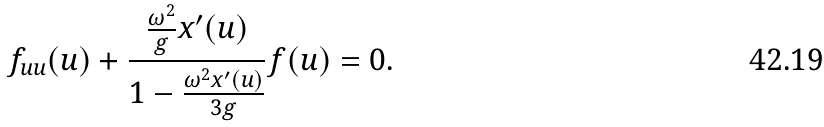Convert formula to latex. <formula><loc_0><loc_0><loc_500><loc_500>f _ { u u } ( u ) + \frac { \frac { \omega ^ { 2 } } { g } x ^ { \prime } ( u ) } { 1 - \frac { \omega ^ { 2 } x ^ { \prime } ( u ) } { 3 g } } f ( u ) = 0 .</formula> 